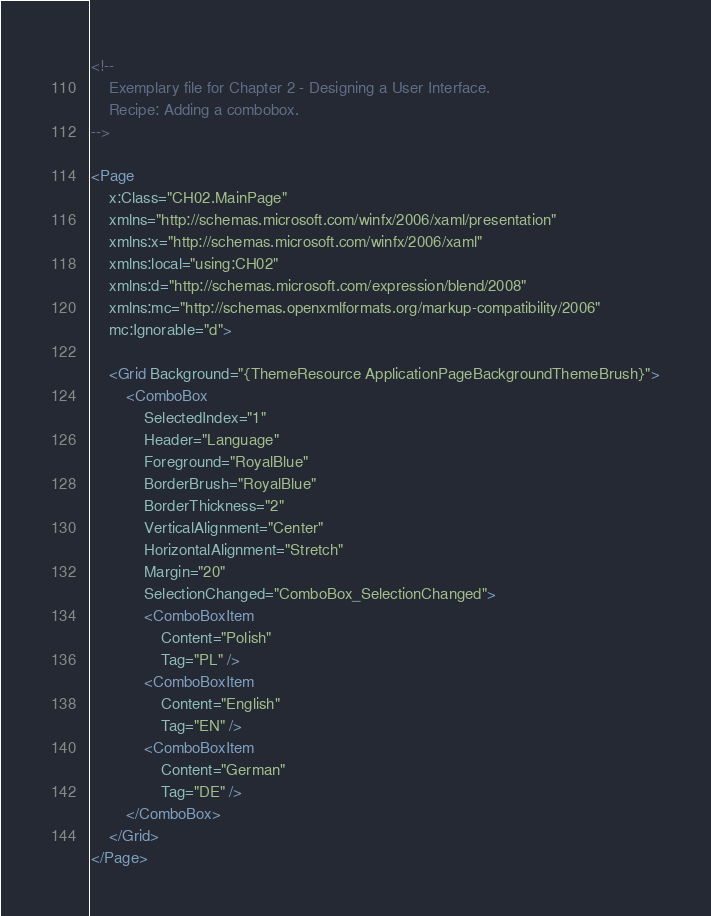<code> <loc_0><loc_0><loc_500><loc_500><_XML_><!--
	Exemplary file for Chapter 2 - Designing a User Interface.
    Recipe: Adding a combobox.
-->

<Page
    x:Class="CH02.MainPage"
    xmlns="http://schemas.microsoft.com/winfx/2006/xaml/presentation"
    xmlns:x="http://schemas.microsoft.com/winfx/2006/xaml"
    xmlns:local="using:CH02"
    xmlns:d="http://schemas.microsoft.com/expression/blend/2008"
    xmlns:mc="http://schemas.openxmlformats.org/markup-compatibility/2006"
    mc:Ignorable="d">

    <Grid Background="{ThemeResource ApplicationPageBackgroundThemeBrush}">
        <ComboBox
            SelectedIndex="1"
            Header="Language"
            Foreground="RoyalBlue"
            BorderBrush="RoyalBlue"
            BorderThickness="2"
            VerticalAlignment="Center"
            HorizontalAlignment="Stretch"
            Margin="20"
            SelectionChanged="ComboBox_SelectionChanged">
            <ComboBoxItem
                Content="Polish"
                Tag="PL" />
            <ComboBoxItem
                Content="English"
                Tag="EN" />
            <ComboBoxItem
                Content="German"
                Tag="DE" />
        </ComboBox>
    </Grid>
</Page>
</code> 